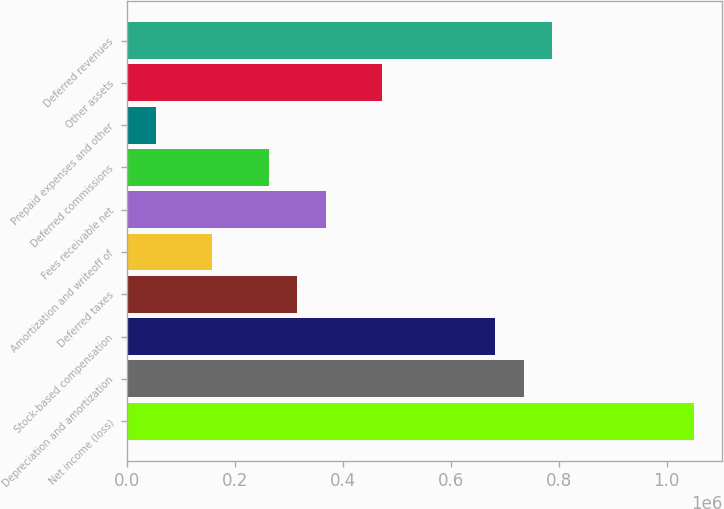<chart> <loc_0><loc_0><loc_500><loc_500><bar_chart><fcel>Net income (loss)<fcel>Depreciation and amortization<fcel>Stock-based compensation<fcel>Deferred taxes<fcel>Amortization and writeoff of<fcel>Fees receivable net<fcel>Deferred commissions<fcel>Prepaid expenses and other<fcel>Other assets<fcel>Deferred revenues<nl><fcel>1.04996e+06<fcel>734986<fcel>682489<fcel>315014<fcel>157525<fcel>367511<fcel>262518<fcel>52532.4<fcel>472504<fcel>787482<nl></chart> 